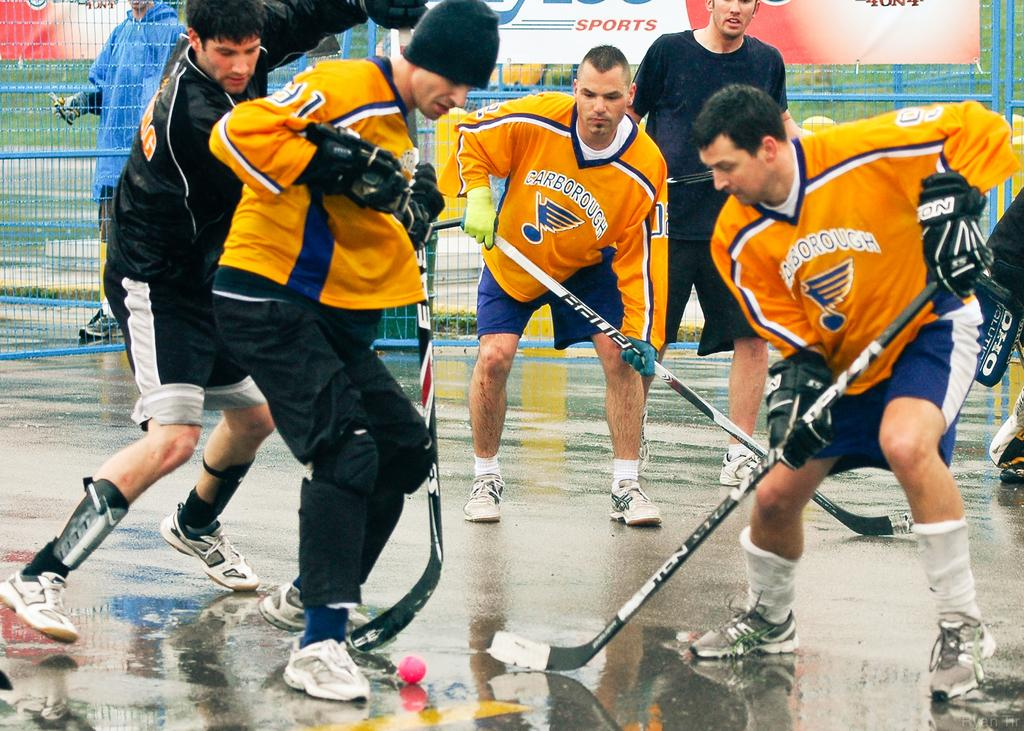<image>
Share a concise interpretation of the image provided. Hockey players wear Carborough jerseys while they play. 